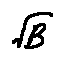<formula> <loc_0><loc_0><loc_500><loc_500>\sqrt { B }</formula> 